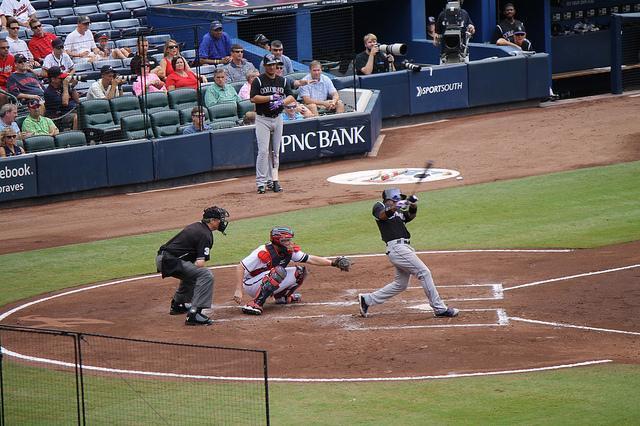How many people are in the photo?
Give a very brief answer. 5. 